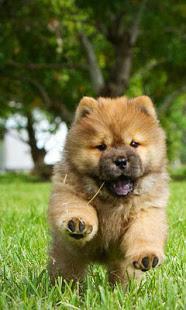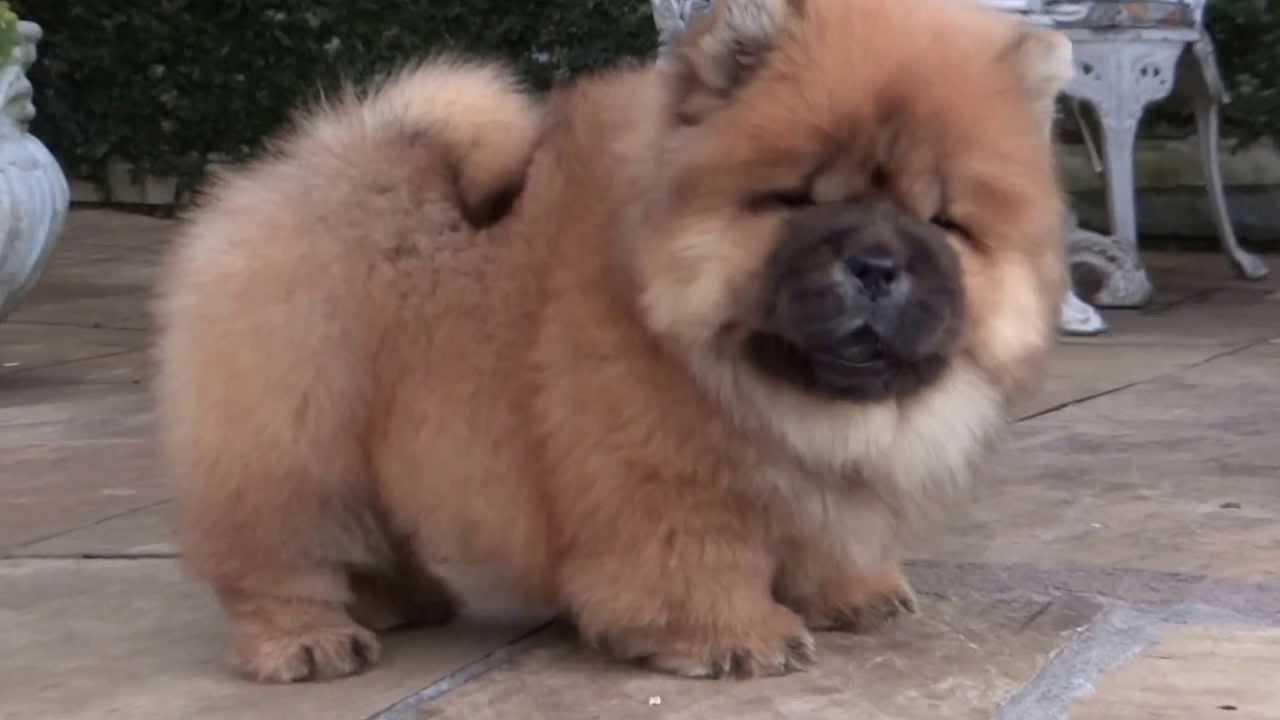The first image is the image on the left, the second image is the image on the right. Examine the images to the left and right. Is the description "One of the images shows a fluffy puppy running over grass toward the camera." accurate? Answer yes or no. Yes. The first image is the image on the left, the second image is the image on the right. Analyze the images presented: Is the assertion "a puppy is leaping in the grass" valid? Answer yes or no. Yes. 